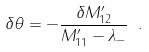Convert formula to latex. <formula><loc_0><loc_0><loc_500><loc_500>\delta \theta = - \frac { \delta M ^ { \prime } _ { 1 2 } } { M ^ { \prime } _ { 1 1 } - \lambda _ { - } } \ .</formula> 